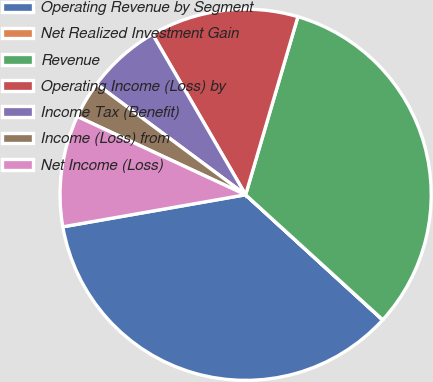Convert chart. <chart><loc_0><loc_0><loc_500><loc_500><pie_chart><fcel>Operating Revenue by Segment<fcel>Net Realized Investment Gain<fcel>Revenue<fcel>Operating Income (Loss) by<fcel>Income Tax (Benefit)<fcel>Income (Loss) from<fcel>Net Income (Loss)<nl><fcel>35.45%<fcel>0.02%<fcel>32.22%<fcel>12.91%<fcel>6.47%<fcel>3.24%<fcel>9.69%<nl></chart> 